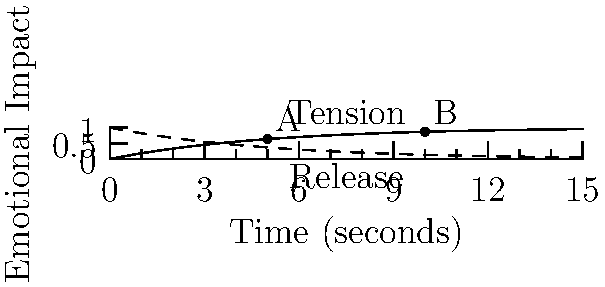In a crucial scene of your screenplay, you want to create a tension-release dynamic inspired by Mikhail Bleiman's editing techniques. The graph shows the emotional impact over time, with the solid line representing tension and the dashed line representing release. If point A occurs at 5 seconds and point B at 10 seconds, what is the rate of change in tension between these two points, and how might this inform your editing choices? To solve this problem, we'll follow these steps:

1) First, we need to determine the tension values at points A and B.
   At point A (5 seconds): $y_A = 1 - e^{-5/5} = 1 - e^{-1} \approx 0.632$
   At point B (10 seconds): $y_B = 1 - e^{-10/5} = 1 - e^{-2} \approx 0.865$

2) Now, we can calculate the rate of change (slope) between these two points:
   Rate of change = $\frac{\text{Change in y}}{\text{Change in x}} = \frac{y_B - y_A}{x_B - x_A}$

3) Plugging in our values:
   Rate of change = $\frac{0.865 - 0.632}{10 - 5} = \frac{0.233}{5} \approx 0.0466$ per second

4) This rate indicates that the tension is increasing by about 0.0466 units per second between points A and B.

5) In terms of editing choices, this gradual increase in tension suggests:
   - Longer shots could be used to build suspense slowly
   - Increasing pace of cuts as you approach point B
   - Intensifying music or sound effects to match the rising tension
   - Focusing on character reactions to heighten emotional impact

6) The release curve (dashed line) shows where tension resolution could be placed for maximum impact, potentially after point B.
Answer: 0.0466 units/second; gradual tension increase suggests longer initial shots, increasing pace of cuts, intensifying audiovisual elements towards climax. 